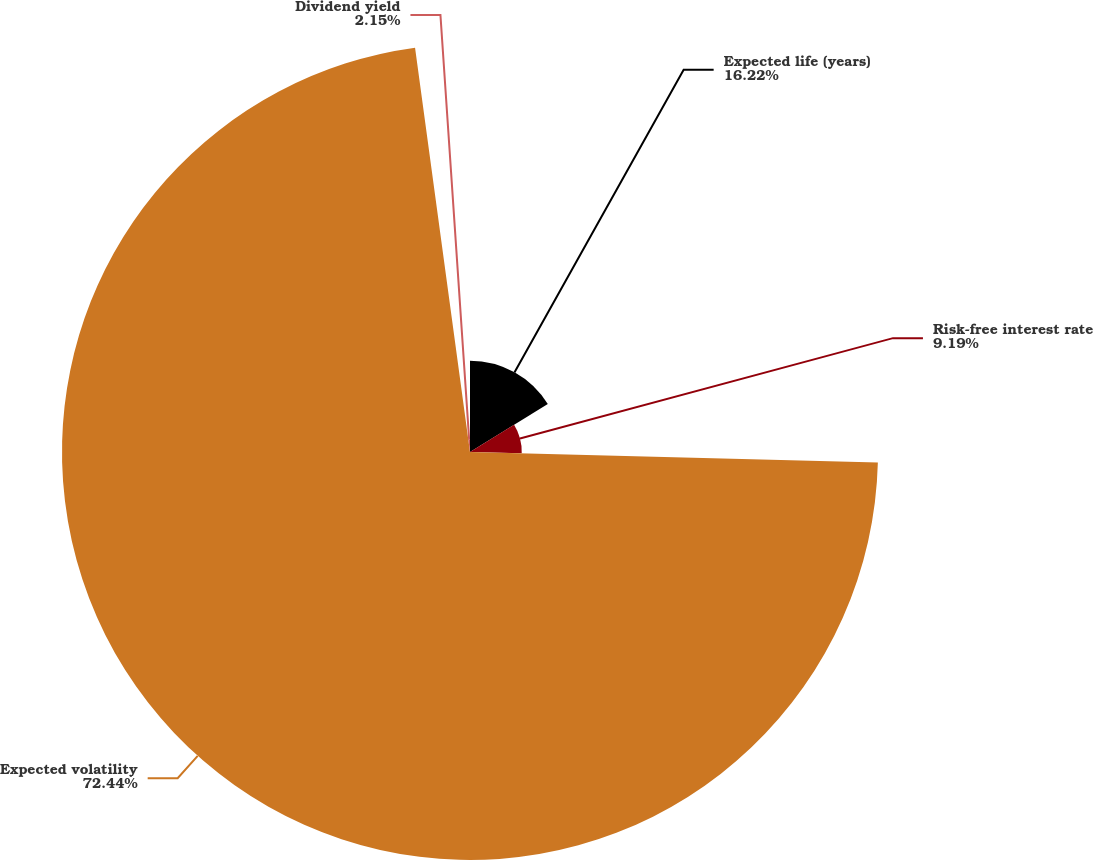Convert chart to OTSL. <chart><loc_0><loc_0><loc_500><loc_500><pie_chart><fcel>Expected life (years)<fcel>Risk-free interest rate<fcel>Expected volatility<fcel>Dividend yield<nl><fcel>16.22%<fcel>9.19%<fcel>72.44%<fcel>2.15%<nl></chart> 